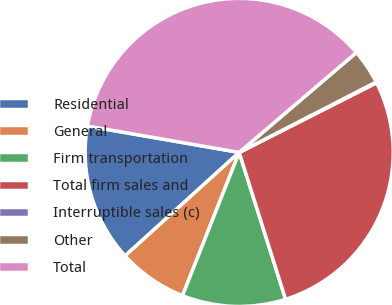Convert chart. <chart><loc_0><loc_0><loc_500><loc_500><pie_chart><fcel>Residential<fcel>General<fcel>Firm transportation<fcel>Total firm sales and<fcel>Interruptible sales (c)<fcel>Other<fcel>Total<nl><fcel>14.46%<fcel>7.28%<fcel>10.87%<fcel>27.59%<fcel>0.09%<fcel>3.68%<fcel>36.02%<nl></chart> 